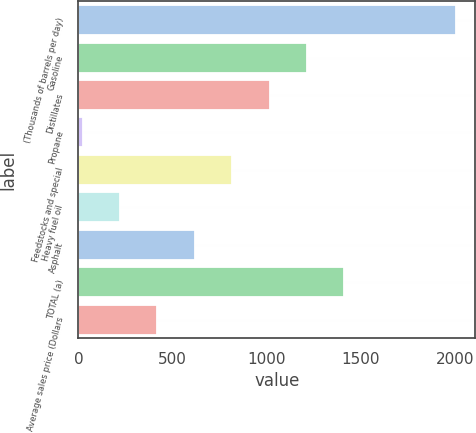Convert chart. <chart><loc_0><loc_0><loc_500><loc_500><bar_chart><fcel>(Thousands of barrels per day)<fcel>Gasoline<fcel>Distillates<fcel>Propane<fcel>Feedstocks and special<fcel>Heavy fuel oil<fcel>Asphalt<fcel>TOTAL (a)<fcel>Average sales price (Dollars<nl><fcel>2007<fcel>1213.4<fcel>1015<fcel>23<fcel>816.6<fcel>221.4<fcel>618.2<fcel>1411.8<fcel>419.8<nl></chart> 